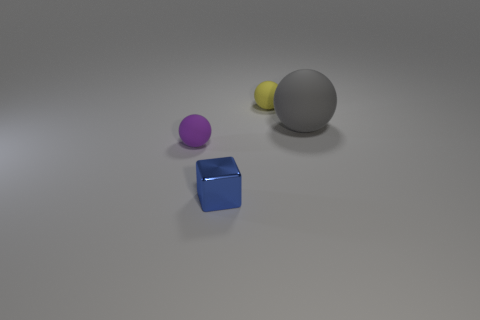Can you describe the sizes and colors of the objects in the image? Certainly! There are four objects in total. Starting from the left, there's a tiny yellow ball, then a small purple ball, a large gray matte ball, and finally a medium-sized blue cube with a slightly reflective surface. 